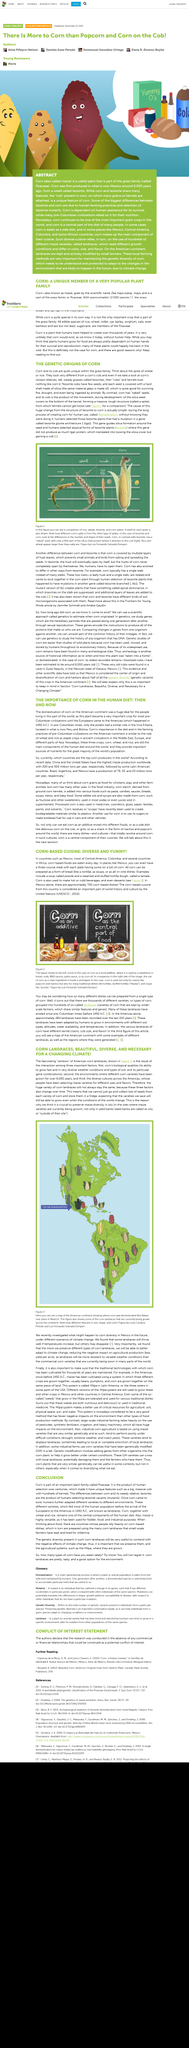Highlight a few significant elements in this photo. Corn-based cuisine is widely enjoyed in Mexico and Colombia, where it is a staple ingredient in many traditional dishes. There are more than 700 corn-based dishes in Mexico, reflecting the importance of corn as a staple food in Mexican cuisine. Corn is a versatile crop that can be used in a variety of ways. Some of the types of things that corn can be used for include making bread, soup, and beverages. Corn is a staple food in many cultures and is also used in animal feed and as a source of ethanol fuel. 